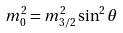<formula> <loc_0><loc_0><loc_500><loc_500>m ^ { 2 } _ { 0 } = m ^ { 2 } _ { 3 / 2 } \sin ^ { 2 } \theta</formula> 